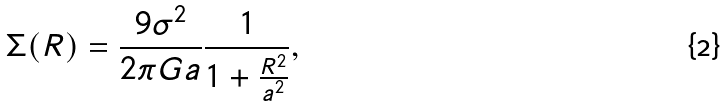<formula> <loc_0><loc_0><loc_500><loc_500>\Sigma ( R ) = \frac { 9 \sigma ^ { 2 } } { 2 \pi G a } \frac { 1 } { 1 + \frac { R ^ { 2 } } { a ^ { 2 } } } ,</formula> 